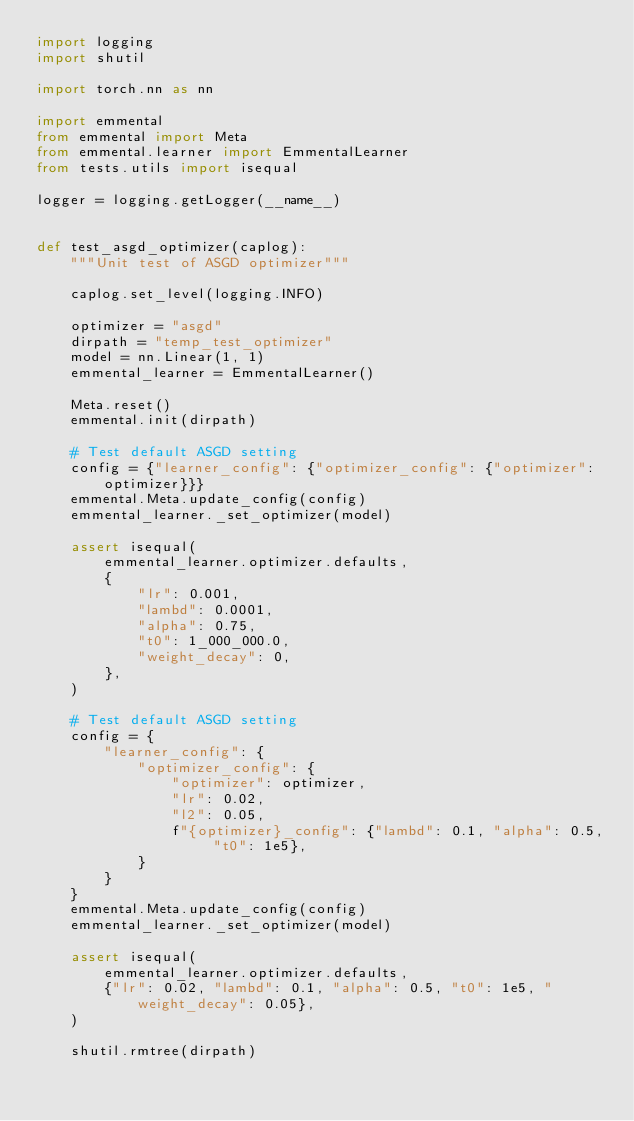<code> <loc_0><loc_0><loc_500><loc_500><_Python_>import logging
import shutil

import torch.nn as nn

import emmental
from emmental import Meta
from emmental.learner import EmmentalLearner
from tests.utils import isequal

logger = logging.getLogger(__name__)


def test_asgd_optimizer(caplog):
    """Unit test of ASGD optimizer"""

    caplog.set_level(logging.INFO)

    optimizer = "asgd"
    dirpath = "temp_test_optimizer"
    model = nn.Linear(1, 1)
    emmental_learner = EmmentalLearner()

    Meta.reset()
    emmental.init(dirpath)

    # Test default ASGD setting
    config = {"learner_config": {"optimizer_config": {"optimizer": optimizer}}}
    emmental.Meta.update_config(config)
    emmental_learner._set_optimizer(model)

    assert isequal(
        emmental_learner.optimizer.defaults,
        {
            "lr": 0.001,
            "lambd": 0.0001,
            "alpha": 0.75,
            "t0": 1_000_000.0,
            "weight_decay": 0,
        },
    )

    # Test default ASGD setting
    config = {
        "learner_config": {
            "optimizer_config": {
                "optimizer": optimizer,
                "lr": 0.02,
                "l2": 0.05,
                f"{optimizer}_config": {"lambd": 0.1, "alpha": 0.5, "t0": 1e5},
            }
        }
    }
    emmental.Meta.update_config(config)
    emmental_learner._set_optimizer(model)

    assert isequal(
        emmental_learner.optimizer.defaults,
        {"lr": 0.02, "lambd": 0.1, "alpha": 0.5, "t0": 1e5, "weight_decay": 0.05},
    )

    shutil.rmtree(dirpath)
</code> 